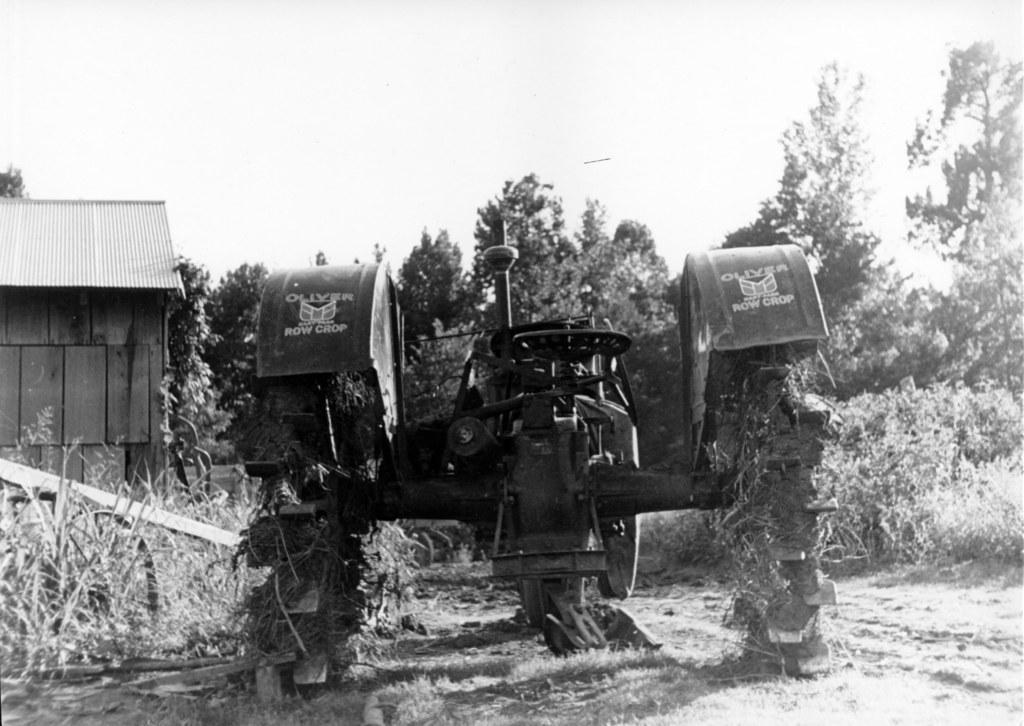How would you summarize this image in a sentence or two? This is a black and white image. In the center of the image we can see a tractor. On the left side of the image we can see a house, roof, wheel, stick. In the background of the image we can see the trees, pants. At the bottom of the image we can see the ground. At the top of the image we can see the sky. 